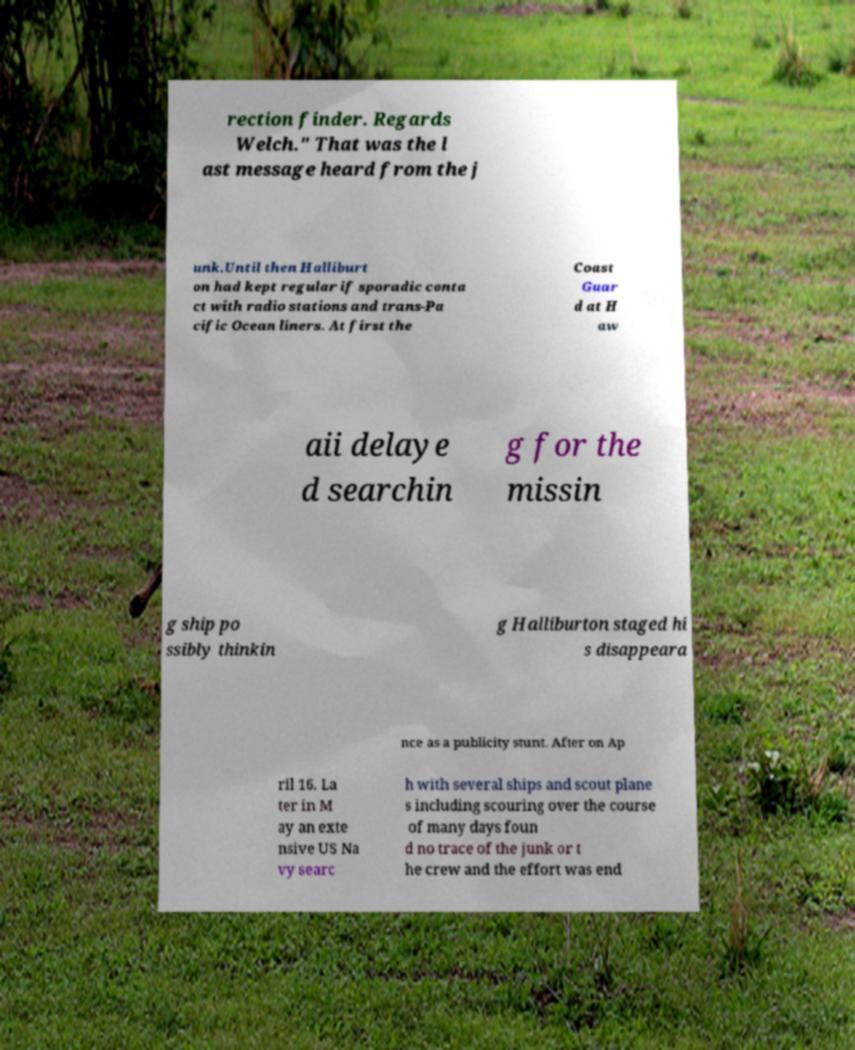Can you accurately transcribe the text from the provided image for me? rection finder. Regards Welch." That was the l ast message heard from the j unk.Until then Halliburt on had kept regular if sporadic conta ct with radio stations and trans-Pa cific Ocean liners. At first the Coast Guar d at H aw aii delaye d searchin g for the missin g ship po ssibly thinkin g Halliburton staged hi s disappeara nce as a publicity stunt. After on Ap ril 16. La ter in M ay an exte nsive US Na vy searc h with several ships and scout plane s including scouring over the course of many days foun d no trace of the junk or t he crew and the effort was end 